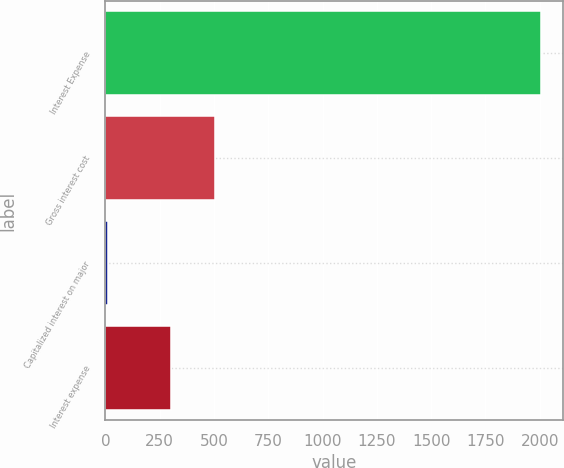<chart> <loc_0><loc_0><loc_500><loc_500><bar_chart><fcel>Interest Expense<fcel>Gross interest cost<fcel>Capitalized interest on major<fcel>Interest expense<nl><fcel>2008<fcel>503.4<fcel>14<fcel>304<nl></chart> 